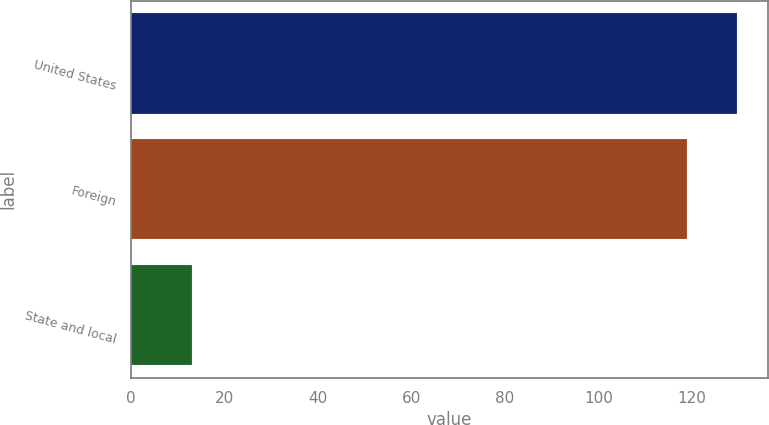<chart> <loc_0><loc_0><loc_500><loc_500><bar_chart><fcel>United States<fcel>Foreign<fcel>State and local<nl><fcel>129.7<fcel>119<fcel>13<nl></chart> 